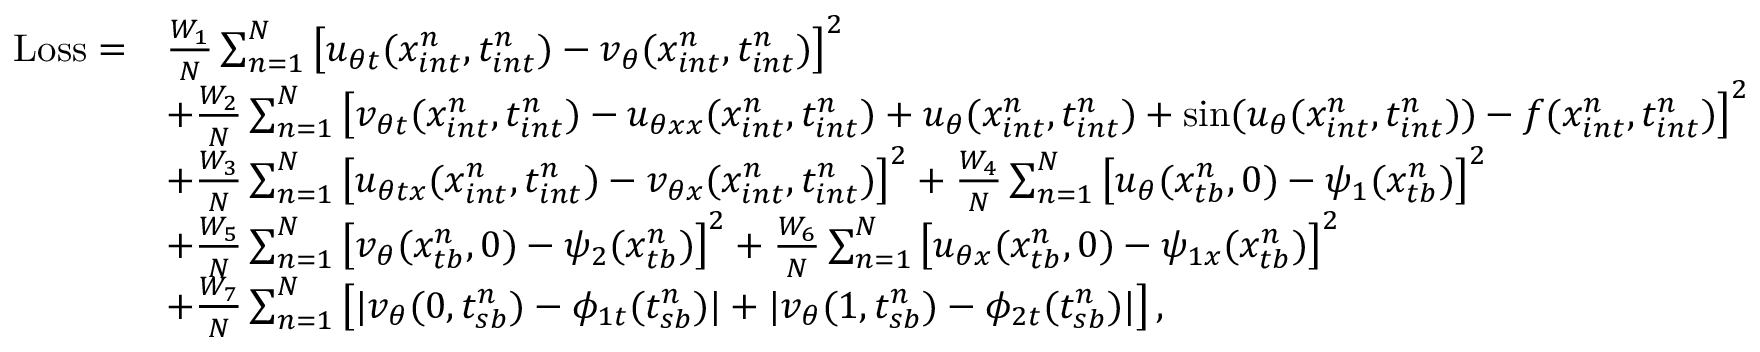Convert formula to latex. <formula><loc_0><loc_0><loc_500><loc_500>\begin{array} { r l } { L o s s = } & { \frac { W _ { 1 } } { N } \sum _ { n = 1 } ^ { N } \left [ u _ { \theta t } ( x _ { i n t } ^ { n } , t _ { i n t } ^ { n } ) - v _ { \theta } ( x _ { i n t } ^ { n } , t _ { i n t } ^ { n } ) \right ] ^ { 2 } } \\ & { + \frac { W _ { 2 } } { N } \sum _ { n = 1 } ^ { N } \left [ v _ { \theta t } ( x _ { i n t } ^ { n } , t _ { i n t } ^ { n } ) - u _ { \theta x x } ( x _ { i n t } ^ { n } , t _ { i n t } ^ { n } ) + u _ { \theta } ( x _ { i n t } ^ { n } , t _ { i n t } ^ { n } ) + \sin ( u _ { \theta } ( x _ { i n t } ^ { n } , t _ { i n t } ^ { n } ) ) - f ( x _ { i n t } ^ { n } , t _ { i n t } ^ { n } ) \right ] ^ { 2 } } \\ & { + \frac { W _ { 3 } } { N } \sum _ { n = 1 } ^ { N } \left [ u _ { \theta t x } ( x _ { i n t } ^ { n } , t _ { i n t } ^ { n } ) - v _ { \theta x } ( x _ { i n t } ^ { n } , t _ { i n t } ^ { n } ) \right ] ^ { 2 } + \frac { W _ { 4 } } { N } \sum _ { n = 1 } ^ { N } \left [ u _ { \theta } ( x _ { t b } ^ { n } , 0 ) - \psi _ { 1 } ( x _ { t b } ^ { n } ) \right ] ^ { 2 } } \\ & { + \frac { W _ { 5 } } { N } \sum _ { n = 1 } ^ { N } \left [ v _ { \theta } ( x _ { t b } ^ { n } , 0 ) - \psi _ { 2 } ( x _ { t b } ^ { n } ) \right ] ^ { 2 } + \frac { W _ { 6 } } { N } \sum _ { n = 1 } ^ { N } \left [ u _ { \theta x } ( x _ { t b } ^ { n } , 0 ) - \psi _ { 1 x } ( x _ { t b } ^ { n } ) \right ] ^ { 2 } } \\ & { + \frac { W _ { 7 } } { N } \sum _ { n = 1 } ^ { N } \left [ | v _ { \theta } ( 0 , t _ { s b } ^ { n } ) - \phi _ { 1 t } ( { t _ { s b } ^ { n } } ) | + | v _ { \theta } ( 1 , t _ { s b } ^ { n } ) - \phi _ { 2 t } ( { t _ { s b } ^ { n } } ) | \right ] , } \end{array}</formula> 